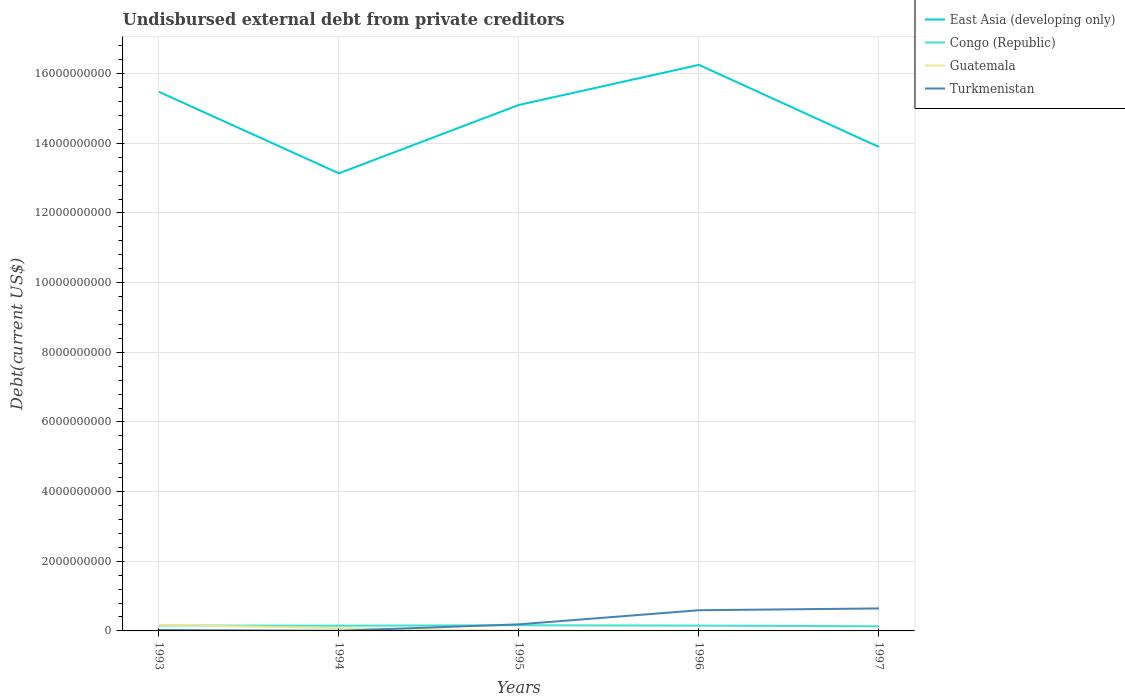Is the number of lines equal to the number of legend labels?
Provide a succinct answer. Yes. Across all years, what is the maximum total debt in East Asia (developing only)?
Keep it short and to the point. 1.31e+1. In which year was the total debt in Congo (Republic) maximum?
Provide a succinct answer. 1997. What is the total total debt in Guatemala in the graph?
Your answer should be compact. 4.01e+06. What is the difference between the highest and the second highest total debt in Turkmenistan?
Your answer should be very brief. 6.41e+08. How many years are there in the graph?
Provide a short and direct response. 5. What is the difference between two consecutive major ticks on the Y-axis?
Offer a very short reply. 2.00e+09. Does the graph contain grids?
Your answer should be very brief. Yes. Where does the legend appear in the graph?
Your answer should be compact. Top right. How are the legend labels stacked?
Your response must be concise. Vertical. What is the title of the graph?
Your answer should be very brief. Undisbursed external debt from private creditors. What is the label or title of the Y-axis?
Provide a short and direct response. Debt(current US$). What is the Debt(current US$) in East Asia (developing only) in 1993?
Offer a terse response. 1.55e+1. What is the Debt(current US$) in Congo (Republic) in 1993?
Give a very brief answer. 1.55e+08. What is the Debt(current US$) in Guatemala in 1993?
Your answer should be compact. 1.73e+08. What is the Debt(current US$) of Turkmenistan in 1993?
Ensure brevity in your answer.  2.70e+07. What is the Debt(current US$) in East Asia (developing only) in 1994?
Ensure brevity in your answer.  1.31e+1. What is the Debt(current US$) in Congo (Republic) in 1994?
Your response must be concise. 1.50e+08. What is the Debt(current US$) of Guatemala in 1994?
Provide a short and direct response. 7.89e+07. What is the Debt(current US$) of Turkmenistan in 1994?
Keep it short and to the point. 4.59e+06. What is the Debt(current US$) in East Asia (developing only) in 1995?
Your answer should be compact. 1.51e+1. What is the Debt(current US$) of Congo (Republic) in 1995?
Ensure brevity in your answer.  1.63e+08. What is the Debt(current US$) of Guatemala in 1995?
Provide a short and direct response. 7.03e+06. What is the Debt(current US$) in Turkmenistan in 1995?
Keep it short and to the point. 1.89e+08. What is the Debt(current US$) in East Asia (developing only) in 1996?
Your answer should be compact. 1.63e+1. What is the Debt(current US$) in Congo (Republic) in 1996?
Give a very brief answer. 1.53e+08. What is the Debt(current US$) in Guatemala in 1996?
Offer a very short reply. 5.85e+06. What is the Debt(current US$) of Turkmenistan in 1996?
Your answer should be very brief. 5.94e+08. What is the Debt(current US$) in East Asia (developing only) in 1997?
Provide a short and direct response. 1.39e+1. What is the Debt(current US$) in Congo (Republic) in 1997?
Offer a very short reply. 1.34e+08. What is the Debt(current US$) of Guatemala in 1997?
Offer a terse response. 1.84e+06. What is the Debt(current US$) of Turkmenistan in 1997?
Provide a short and direct response. 6.46e+08. Across all years, what is the maximum Debt(current US$) in East Asia (developing only)?
Your answer should be compact. 1.63e+1. Across all years, what is the maximum Debt(current US$) in Congo (Republic)?
Give a very brief answer. 1.63e+08. Across all years, what is the maximum Debt(current US$) of Guatemala?
Your response must be concise. 1.73e+08. Across all years, what is the maximum Debt(current US$) in Turkmenistan?
Your answer should be compact. 6.46e+08. Across all years, what is the minimum Debt(current US$) of East Asia (developing only)?
Your answer should be compact. 1.31e+1. Across all years, what is the minimum Debt(current US$) of Congo (Republic)?
Give a very brief answer. 1.34e+08. Across all years, what is the minimum Debt(current US$) of Guatemala?
Make the answer very short. 1.84e+06. Across all years, what is the minimum Debt(current US$) in Turkmenistan?
Provide a short and direct response. 4.59e+06. What is the total Debt(current US$) of East Asia (developing only) in the graph?
Offer a very short reply. 7.39e+1. What is the total Debt(current US$) of Congo (Republic) in the graph?
Your answer should be compact. 7.55e+08. What is the total Debt(current US$) in Guatemala in the graph?
Your answer should be very brief. 2.66e+08. What is the total Debt(current US$) in Turkmenistan in the graph?
Offer a very short reply. 1.46e+09. What is the difference between the Debt(current US$) of East Asia (developing only) in 1993 and that in 1994?
Your answer should be very brief. 2.34e+09. What is the difference between the Debt(current US$) of Congo (Republic) in 1993 and that in 1994?
Provide a succinct answer. 4.70e+06. What is the difference between the Debt(current US$) in Guatemala in 1993 and that in 1994?
Provide a short and direct response. 9.38e+07. What is the difference between the Debt(current US$) of Turkmenistan in 1993 and that in 1994?
Your answer should be very brief. 2.25e+07. What is the difference between the Debt(current US$) in East Asia (developing only) in 1993 and that in 1995?
Offer a terse response. 3.78e+08. What is the difference between the Debt(current US$) in Congo (Republic) in 1993 and that in 1995?
Make the answer very short. -8.08e+06. What is the difference between the Debt(current US$) of Guatemala in 1993 and that in 1995?
Offer a terse response. 1.66e+08. What is the difference between the Debt(current US$) of Turkmenistan in 1993 and that in 1995?
Make the answer very short. -1.62e+08. What is the difference between the Debt(current US$) in East Asia (developing only) in 1993 and that in 1996?
Keep it short and to the point. -7.72e+08. What is the difference between the Debt(current US$) of Congo (Republic) in 1993 and that in 1996?
Offer a very short reply. 2.43e+06. What is the difference between the Debt(current US$) in Guatemala in 1993 and that in 1996?
Your answer should be compact. 1.67e+08. What is the difference between the Debt(current US$) of Turkmenistan in 1993 and that in 1996?
Provide a succinct answer. -5.67e+08. What is the difference between the Debt(current US$) in East Asia (developing only) in 1993 and that in 1997?
Offer a very short reply. 1.58e+09. What is the difference between the Debt(current US$) in Congo (Republic) in 1993 and that in 1997?
Your answer should be very brief. 2.16e+07. What is the difference between the Debt(current US$) of Guatemala in 1993 and that in 1997?
Give a very brief answer. 1.71e+08. What is the difference between the Debt(current US$) of Turkmenistan in 1993 and that in 1997?
Provide a succinct answer. -6.19e+08. What is the difference between the Debt(current US$) of East Asia (developing only) in 1994 and that in 1995?
Offer a very short reply. -1.96e+09. What is the difference between the Debt(current US$) of Congo (Republic) in 1994 and that in 1995?
Make the answer very short. -1.28e+07. What is the difference between the Debt(current US$) of Guatemala in 1994 and that in 1995?
Give a very brief answer. 7.19e+07. What is the difference between the Debt(current US$) in Turkmenistan in 1994 and that in 1995?
Keep it short and to the point. -1.84e+08. What is the difference between the Debt(current US$) in East Asia (developing only) in 1994 and that in 1996?
Offer a very short reply. -3.11e+09. What is the difference between the Debt(current US$) of Congo (Republic) in 1994 and that in 1996?
Provide a succinct answer. -2.27e+06. What is the difference between the Debt(current US$) in Guatemala in 1994 and that in 1996?
Offer a terse response. 7.30e+07. What is the difference between the Debt(current US$) of Turkmenistan in 1994 and that in 1996?
Your response must be concise. -5.89e+08. What is the difference between the Debt(current US$) of East Asia (developing only) in 1994 and that in 1997?
Your response must be concise. -7.57e+08. What is the difference between the Debt(current US$) in Congo (Republic) in 1994 and that in 1997?
Keep it short and to the point. 1.69e+07. What is the difference between the Debt(current US$) of Guatemala in 1994 and that in 1997?
Your response must be concise. 7.70e+07. What is the difference between the Debt(current US$) in Turkmenistan in 1994 and that in 1997?
Your response must be concise. -6.41e+08. What is the difference between the Debt(current US$) of East Asia (developing only) in 1995 and that in 1996?
Keep it short and to the point. -1.15e+09. What is the difference between the Debt(current US$) of Congo (Republic) in 1995 and that in 1996?
Provide a short and direct response. 1.05e+07. What is the difference between the Debt(current US$) in Guatemala in 1995 and that in 1996?
Your answer should be very brief. 1.18e+06. What is the difference between the Debt(current US$) of Turkmenistan in 1995 and that in 1996?
Offer a very short reply. -4.05e+08. What is the difference between the Debt(current US$) in East Asia (developing only) in 1995 and that in 1997?
Give a very brief answer. 1.21e+09. What is the difference between the Debt(current US$) of Congo (Republic) in 1995 and that in 1997?
Your answer should be compact. 2.97e+07. What is the difference between the Debt(current US$) in Guatemala in 1995 and that in 1997?
Give a very brief answer. 5.19e+06. What is the difference between the Debt(current US$) of Turkmenistan in 1995 and that in 1997?
Offer a very short reply. -4.57e+08. What is the difference between the Debt(current US$) of East Asia (developing only) in 1996 and that in 1997?
Offer a very short reply. 2.36e+09. What is the difference between the Debt(current US$) of Congo (Republic) in 1996 and that in 1997?
Provide a succinct answer. 1.92e+07. What is the difference between the Debt(current US$) in Guatemala in 1996 and that in 1997?
Offer a very short reply. 4.01e+06. What is the difference between the Debt(current US$) of Turkmenistan in 1996 and that in 1997?
Ensure brevity in your answer.  -5.17e+07. What is the difference between the Debt(current US$) in East Asia (developing only) in 1993 and the Debt(current US$) in Congo (Republic) in 1994?
Provide a short and direct response. 1.53e+1. What is the difference between the Debt(current US$) of East Asia (developing only) in 1993 and the Debt(current US$) of Guatemala in 1994?
Make the answer very short. 1.54e+1. What is the difference between the Debt(current US$) in East Asia (developing only) in 1993 and the Debt(current US$) in Turkmenistan in 1994?
Offer a very short reply. 1.55e+1. What is the difference between the Debt(current US$) in Congo (Republic) in 1993 and the Debt(current US$) in Guatemala in 1994?
Your answer should be very brief. 7.63e+07. What is the difference between the Debt(current US$) in Congo (Republic) in 1993 and the Debt(current US$) in Turkmenistan in 1994?
Your response must be concise. 1.51e+08. What is the difference between the Debt(current US$) of Guatemala in 1993 and the Debt(current US$) of Turkmenistan in 1994?
Keep it short and to the point. 1.68e+08. What is the difference between the Debt(current US$) of East Asia (developing only) in 1993 and the Debt(current US$) of Congo (Republic) in 1995?
Your answer should be very brief. 1.53e+1. What is the difference between the Debt(current US$) of East Asia (developing only) in 1993 and the Debt(current US$) of Guatemala in 1995?
Your answer should be compact. 1.55e+1. What is the difference between the Debt(current US$) of East Asia (developing only) in 1993 and the Debt(current US$) of Turkmenistan in 1995?
Offer a terse response. 1.53e+1. What is the difference between the Debt(current US$) in Congo (Republic) in 1993 and the Debt(current US$) in Guatemala in 1995?
Provide a short and direct response. 1.48e+08. What is the difference between the Debt(current US$) of Congo (Republic) in 1993 and the Debt(current US$) of Turkmenistan in 1995?
Provide a succinct answer. -3.35e+07. What is the difference between the Debt(current US$) of Guatemala in 1993 and the Debt(current US$) of Turkmenistan in 1995?
Give a very brief answer. -1.60e+07. What is the difference between the Debt(current US$) in East Asia (developing only) in 1993 and the Debt(current US$) in Congo (Republic) in 1996?
Provide a short and direct response. 1.53e+1. What is the difference between the Debt(current US$) in East Asia (developing only) in 1993 and the Debt(current US$) in Guatemala in 1996?
Offer a terse response. 1.55e+1. What is the difference between the Debt(current US$) of East Asia (developing only) in 1993 and the Debt(current US$) of Turkmenistan in 1996?
Give a very brief answer. 1.49e+1. What is the difference between the Debt(current US$) of Congo (Republic) in 1993 and the Debt(current US$) of Guatemala in 1996?
Give a very brief answer. 1.49e+08. What is the difference between the Debt(current US$) of Congo (Republic) in 1993 and the Debt(current US$) of Turkmenistan in 1996?
Your answer should be compact. -4.39e+08. What is the difference between the Debt(current US$) in Guatemala in 1993 and the Debt(current US$) in Turkmenistan in 1996?
Provide a succinct answer. -4.21e+08. What is the difference between the Debt(current US$) of East Asia (developing only) in 1993 and the Debt(current US$) of Congo (Republic) in 1997?
Your response must be concise. 1.53e+1. What is the difference between the Debt(current US$) in East Asia (developing only) in 1993 and the Debt(current US$) in Guatemala in 1997?
Provide a short and direct response. 1.55e+1. What is the difference between the Debt(current US$) in East Asia (developing only) in 1993 and the Debt(current US$) in Turkmenistan in 1997?
Your answer should be compact. 1.48e+1. What is the difference between the Debt(current US$) in Congo (Republic) in 1993 and the Debt(current US$) in Guatemala in 1997?
Make the answer very short. 1.53e+08. What is the difference between the Debt(current US$) in Congo (Republic) in 1993 and the Debt(current US$) in Turkmenistan in 1997?
Offer a terse response. -4.90e+08. What is the difference between the Debt(current US$) in Guatemala in 1993 and the Debt(current US$) in Turkmenistan in 1997?
Offer a terse response. -4.73e+08. What is the difference between the Debt(current US$) of East Asia (developing only) in 1994 and the Debt(current US$) of Congo (Republic) in 1995?
Keep it short and to the point. 1.30e+1. What is the difference between the Debt(current US$) of East Asia (developing only) in 1994 and the Debt(current US$) of Guatemala in 1995?
Give a very brief answer. 1.31e+1. What is the difference between the Debt(current US$) of East Asia (developing only) in 1994 and the Debt(current US$) of Turkmenistan in 1995?
Offer a terse response. 1.29e+1. What is the difference between the Debt(current US$) in Congo (Republic) in 1994 and the Debt(current US$) in Guatemala in 1995?
Your answer should be very brief. 1.43e+08. What is the difference between the Debt(current US$) of Congo (Republic) in 1994 and the Debt(current US$) of Turkmenistan in 1995?
Your answer should be compact. -3.82e+07. What is the difference between the Debt(current US$) of Guatemala in 1994 and the Debt(current US$) of Turkmenistan in 1995?
Keep it short and to the point. -1.10e+08. What is the difference between the Debt(current US$) of East Asia (developing only) in 1994 and the Debt(current US$) of Congo (Republic) in 1996?
Ensure brevity in your answer.  1.30e+1. What is the difference between the Debt(current US$) in East Asia (developing only) in 1994 and the Debt(current US$) in Guatemala in 1996?
Give a very brief answer. 1.31e+1. What is the difference between the Debt(current US$) in East Asia (developing only) in 1994 and the Debt(current US$) in Turkmenistan in 1996?
Ensure brevity in your answer.  1.25e+1. What is the difference between the Debt(current US$) in Congo (Republic) in 1994 and the Debt(current US$) in Guatemala in 1996?
Provide a short and direct response. 1.45e+08. What is the difference between the Debt(current US$) of Congo (Republic) in 1994 and the Debt(current US$) of Turkmenistan in 1996?
Offer a very short reply. -4.43e+08. What is the difference between the Debt(current US$) in Guatemala in 1994 and the Debt(current US$) in Turkmenistan in 1996?
Offer a terse response. -5.15e+08. What is the difference between the Debt(current US$) of East Asia (developing only) in 1994 and the Debt(current US$) of Congo (Republic) in 1997?
Offer a terse response. 1.30e+1. What is the difference between the Debt(current US$) of East Asia (developing only) in 1994 and the Debt(current US$) of Guatemala in 1997?
Your answer should be compact. 1.31e+1. What is the difference between the Debt(current US$) of East Asia (developing only) in 1994 and the Debt(current US$) of Turkmenistan in 1997?
Your answer should be very brief. 1.25e+1. What is the difference between the Debt(current US$) of Congo (Republic) in 1994 and the Debt(current US$) of Guatemala in 1997?
Provide a succinct answer. 1.49e+08. What is the difference between the Debt(current US$) in Congo (Republic) in 1994 and the Debt(current US$) in Turkmenistan in 1997?
Ensure brevity in your answer.  -4.95e+08. What is the difference between the Debt(current US$) in Guatemala in 1994 and the Debt(current US$) in Turkmenistan in 1997?
Ensure brevity in your answer.  -5.67e+08. What is the difference between the Debt(current US$) in East Asia (developing only) in 1995 and the Debt(current US$) in Congo (Republic) in 1996?
Give a very brief answer. 1.49e+1. What is the difference between the Debt(current US$) in East Asia (developing only) in 1995 and the Debt(current US$) in Guatemala in 1996?
Your answer should be compact. 1.51e+1. What is the difference between the Debt(current US$) of East Asia (developing only) in 1995 and the Debt(current US$) of Turkmenistan in 1996?
Keep it short and to the point. 1.45e+1. What is the difference between the Debt(current US$) in Congo (Republic) in 1995 and the Debt(current US$) in Guatemala in 1996?
Keep it short and to the point. 1.57e+08. What is the difference between the Debt(current US$) in Congo (Republic) in 1995 and the Debt(current US$) in Turkmenistan in 1996?
Offer a very short reply. -4.31e+08. What is the difference between the Debt(current US$) in Guatemala in 1995 and the Debt(current US$) in Turkmenistan in 1996?
Provide a succinct answer. -5.87e+08. What is the difference between the Debt(current US$) in East Asia (developing only) in 1995 and the Debt(current US$) in Congo (Republic) in 1997?
Ensure brevity in your answer.  1.50e+1. What is the difference between the Debt(current US$) in East Asia (developing only) in 1995 and the Debt(current US$) in Guatemala in 1997?
Your answer should be compact. 1.51e+1. What is the difference between the Debt(current US$) in East Asia (developing only) in 1995 and the Debt(current US$) in Turkmenistan in 1997?
Your response must be concise. 1.45e+1. What is the difference between the Debt(current US$) of Congo (Republic) in 1995 and the Debt(current US$) of Guatemala in 1997?
Your answer should be very brief. 1.61e+08. What is the difference between the Debt(current US$) in Congo (Republic) in 1995 and the Debt(current US$) in Turkmenistan in 1997?
Make the answer very short. -4.82e+08. What is the difference between the Debt(current US$) in Guatemala in 1995 and the Debt(current US$) in Turkmenistan in 1997?
Ensure brevity in your answer.  -6.39e+08. What is the difference between the Debt(current US$) in East Asia (developing only) in 1996 and the Debt(current US$) in Congo (Republic) in 1997?
Give a very brief answer. 1.61e+1. What is the difference between the Debt(current US$) of East Asia (developing only) in 1996 and the Debt(current US$) of Guatemala in 1997?
Your answer should be very brief. 1.63e+1. What is the difference between the Debt(current US$) in East Asia (developing only) in 1996 and the Debt(current US$) in Turkmenistan in 1997?
Your response must be concise. 1.56e+1. What is the difference between the Debt(current US$) of Congo (Republic) in 1996 and the Debt(current US$) of Guatemala in 1997?
Provide a succinct answer. 1.51e+08. What is the difference between the Debt(current US$) of Congo (Republic) in 1996 and the Debt(current US$) of Turkmenistan in 1997?
Provide a short and direct response. -4.93e+08. What is the difference between the Debt(current US$) of Guatemala in 1996 and the Debt(current US$) of Turkmenistan in 1997?
Your response must be concise. -6.40e+08. What is the average Debt(current US$) in East Asia (developing only) per year?
Offer a very short reply. 1.48e+1. What is the average Debt(current US$) in Congo (Republic) per year?
Offer a very short reply. 1.51e+08. What is the average Debt(current US$) of Guatemala per year?
Ensure brevity in your answer.  5.33e+07. What is the average Debt(current US$) of Turkmenistan per year?
Provide a short and direct response. 2.92e+08. In the year 1993, what is the difference between the Debt(current US$) in East Asia (developing only) and Debt(current US$) in Congo (Republic)?
Your answer should be compact. 1.53e+1. In the year 1993, what is the difference between the Debt(current US$) in East Asia (developing only) and Debt(current US$) in Guatemala?
Provide a short and direct response. 1.53e+1. In the year 1993, what is the difference between the Debt(current US$) of East Asia (developing only) and Debt(current US$) of Turkmenistan?
Make the answer very short. 1.55e+1. In the year 1993, what is the difference between the Debt(current US$) of Congo (Republic) and Debt(current US$) of Guatemala?
Ensure brevity in your answer.  -1.75e+07. In the year 1993, what is the difference between the Debt(current US$) of Congo (Republic) and Debt(current US$) of Turkmenistan?
Your answer should be very brief. 1.28e+08. In the year 1993, what is the difference between the Debt(current US$) of Guatemala and Debt(current US$) of Turkmenistan?
Make the answer very short. 1.46e+08. In the year 1994, what is the difference between the Debt(current US$) of East Asia (developing only) and Debt(current US$) of Congo (Republic)?
Offer a terse response. 1.30e+1. In the year 1994, what is the difference between the Debt(current US$) of East Asia (developing only) and Debt(current US$) of Guatemala?
Provide a succinct answer. 1.31e+1. In the year 1994, what is the difference between the Debt(current US$) in East Asia (developing only) and Debt(current US$) in Turkmenistan?
Offer a very short reply. 1.31e+1. In the year 1994, what is the difference between the Debt(current US$) of Congo (Republic) and Debt(current US$) of Guatemala?
Provide a succinct answer. 7.16e+07. In the year 1994, what is the difference between the Debt(current US$) in Congo (Republic) and Debt(current US$) in Turkmenistan?
Offer a terse response. 1.46e+08. In the year 1994, what is the difference between the Debt(current US$) of Guatemala and Debt(current US$) of Turkmenistan?
Ensure brevity in your answer.  7.43e+07. In the year 1995, what is the difference between the Debt(current US$) in East Asia (developing only) and Debt(current US$) in Congo (Republic)?
Ensure brevity in your answer.  1.49e+1. In the year 1995, what is the difference between the Debt(current US$) in East Asia (developing only) and Debt(current US$) in Guatemala?
Ensure brevity in your answer.  1.51e+1. In the year 1995, what is the difference between the Debt(current US$) of East Asia (developing only) and Debt(current US$) of Turkmenistan?
Offer a terse response. 1.49e+1. In the year 1995, what is the difference between the Debt(current US$) of Congo (Republic) and Debt(current US$) of Guatemala?
Your answer should be compact. 1.56e+08. In the year 1995, what is the difference between the Debt(current US$) of Congo (Republic) and Debt(current US$) of Turkmenistan?
Your answer should be compact. -2.54e+07. In the year 1995, what is the difference between the Debt(current US$) in Guatemala and Debt(current US$) in Turkmenistan?
Offer a terse response. -1.82e+08. In the year 1996, what is the difference between the Debt(current US$) of East Asia (developing only) and Debt(current US$) of Congo (Republic)?
Your answer should be very brief. 1.61e+1. In the year 1996, what is the difference between the Debt(current US$) in East Asia (developing only) and Debt(current US$) in Guatemala?
Offer a terse response. 1.62e+1. In the year 1996, what is the difference between the Debt(current US$) of East Asia (developing only) and Debt(current US$) of Turkmenistan?
Provide a succinct answer. 1.57e+1. In the year 1996, what is the difference between the Debt(current US$) in Congo (Republic) and Debt(current US$) in Guatemala?
Offer a very short reply. 1.47e+08. In the year 1996, what is the difference between the Debt(current US$) in Congo (Republic) and Debt(current US$) in Turkmenistan?
Keep it short and to the point. -4.41e+08. In the year 1996, what is the difference between the Debt(current US$) in Guatemala and Debt(current US$) in Turkmenistan?
Make the answer very short. -5.88e+08. In the year 1997, what is the difference between the Debt(current US$) in East Asia (developing only) and Debt(current US$) in Congo (Republic)?
Your answer should be very brief. 1.38e+1. In the year 1997, what is the difference between the Debt(current US$) in East Asia (developing only) and Debt(current US$) in Guatemala?
Give a very brief answer. 1.39e+1. In the year 1997, what is the difference between the Debt(current US$) of East Asia (developing only) and Debt(current US$) of Turkmenistan?
Your answer should be very brief. 1.32e+1. In the year 1997, what is the difference between the Debt(current US$) of Congo (Republic) and Debt(current US$) of Guatemala?
Your answer should be very brief. 1.32e+08. In the year 1997, what is the difference between the Debt(current US$) of Congo (Republic) and Debt(current US$) of Turkmenistan?
Offer a very short reply. -5.12e+08. In the year 1997, what is the difference between the Debt(current US$) in Guatemala and Debt(current US$) in Turkmenistan?
Offer a very short reply. -6.44e+08. What is the ratio of the Debt(current US$) of East Asia (developing only) in 1993 to that in 1994?
Offer a terse response. 1.18. What is the ratio of the Debt(current US$) in Congo (Republic) in 1993 to that in 1994?
Your answer should be compact. 1.03. What is the ratio of the Debt(current US$) in Guatemala in 1993 to that in 1994?
Keep it short and to the point. 2.19. What is the ratio of the Debt(current US$) of Turkmenistan in 1993 to that in 1994?
Keep it short and to the point. 5.9. What is the ratio of the Debt(current US$) of East Asia (developing only) in 1993 to that in 1995?
Provide a succinct answer. 1.02. What is the ratio of the Debt(current US$) in Congo (Republic) in 1993 to that in 1995?
Offer a terse response. 0.95. What is the ratio of the Debt(current US$) of Guatemala in 1993 to that in 1995?
Provide a succinct answer. 24.56. What is the ratio of the Debt(current US$) in Turkmenistan in 1993 to that in 1995?
Keep it short and to the point. 0.14. What is the ratio of the Debt(current US$) of East Asia (developing only) in 1993 to that in 1996?
Make the answer very short. 0.95. What is the ratio of the Debt(current US$) of Congo (Republic) in 1993 to that in 1996?
Provide a succinct answer. 1.02. What is the ratio of the Debt(current US$) in Guatemala in 1993 to that in 1996?
Offer a terse response. 29.51. What is the ratio of the Debt(current US$) in Turkmenistan in 1993 to that in 1996?
Provide a short and direct response. 0.05. What is the ratio of the Debt(current US$) in East Asia (developing only) in 1993 to that in 1997?
Provide a short and direct response. 1.11. What is the ratio of the Debt(current US$) in Congo (Republic) in 1993 to that in 1997?
Make the answer very short. 1.16. What is the ratio of the Debt(current US$) of Guatemala in 1993 to that in 1997?
Your answer should be very brief. 93.64. What is the ratio of the Debt(current US$) of Turkmenistan in 1993 to that in 1997?
Your response must be concise. 0.04. What is the ratio of the Debt(current US$) in East Asia (developing only) in 1994 to that in 1995?
Offer a terse response. 0.87. What is the ratio of the Debt(current US$) in Congo (Republic) in 1994 to that in 1995?
Make the answer very short. 0.92. What is the ratio of the Debt(current US$) of Guatemala in 1994 to that in 1995?
Provide a succinct answer. 11.22. What is the ratio of the Debt(current US$) of Turkmenistan in 1994 to that in 1995?
Offer a terse response. 0.02. What is the ratio of the Debt(current US$) in East Asia (developing only) in 1994 to that in 1996?
Give a very brief answer. 0.81. What is the ratio of the Debt(current US$) in Congo (Republic) in 1994 to that in 1996?
Your response must be concise. 0.99. What is the ratio of the Debt(current US$) in Guatemala in 1994 to that in 1996?
Give a very brief answer. 13.48. What is the ratio of the Debt(current US$) in Turkmenistan in 1994 to that in 1996?
Make the answer very short. 0.01. What is the ratio of the Debt(current US$) in East Asia (developing only) in 1994 to that in 1997?
Provide a short and direct response. 0.95. What is the ratio of the Debt(current US$) in Congo (Republic) in 1994 to that in 1997?
Provide a succinct answer. 1.13. What is the ratio of the Debt(current US$) in Guatemala in 1994 to that in 1997?
Ensure brevity in your answer.  42.78. What is the ratio of the Debt(current US$) in Turkmenistan in 1994 to that in 1997?
Keep it short and to the point. 0.01. What is the ratio of the Debt(current US$) in East Asia (developing only) in 1995 to that in 1996?
Keep it short and to the point. 0.93. What is the ratio of the Debt(current US$) in Congo (Republic) in 1995 to that in 1996?
Provide a succinct answer. 1.07. What is the ratio of the Debt(current US$) in Guatemala in 1995 to that in 1996?
Provide a short and direct response. 1.2. What is the ratio of the Debt(current US$) of Turkmenistan in 1995 to that in 1996?
Your response must be concise. 0.32. What is the ratio of the Debt(current US$) in East Asia (developing only) in 1995 to that in 1997?
Provide a succinct answer. 1.09. What is the ratio of the Debt(current US$) of Congo (Republic) in 1995 to that in 1997?
Offer a very short reply. 1.22. What is the ratio of the Debt(current US$) in Guatemala in 1995 to that in 1997?
Keep it short and to the point. 3.81. What is the ratio of the Debt(current US$) of Turkmenistan in 1995 to that in 1997?
Provide a succinct answer. 0.29. What is the ratio of the Debt(current US$) in East Asia (developing only) in 1996 to that in 1997?
Keep it short and to the point. 1.17. What is the ratio of the Debt(current US$) of Congo (Republic) in 1996 to that in 1997?
Make the answer very short. 1.14. What is the ratio of the Debt(current US$) in Guatemala in 1996 to that in 1997?
Your response must be concise. 3.17. What is the difference between the highest and the second highest Debt(current US$) in East Asia (developing only)?
Give a very brief answer. 7.72e+08. What is the difference between the highest and the second highest Debt(current US$) in Congo (Republic)?
Keep it short and to the point. 8.08e+06. What is the difference between the highest and the second highest Debt(current US$) in Guatemala?
Ensure brevity in your answer.  9.38e+07. What is the difference between the highest and the second highest Debt(current US$) in Turkmenistan?
Provide a succinct answer. 5.17e+07. What is the difference between the highest and the lowest Debt(current US$) of East Asia (developing only)?
Offer a terse response. 3.11e+09. What is the difference between the highest and the lowest Debt(current US$) of Congo (Republic)?
Your response must be concise. 2.97e+07. What is the difference between the highest and the lowest Debt(current US$) in Guatemala?
Offer a very short reply. 1.71e+08. What is the difference between the highest and the lowest Debt(current US$) in Turkmenistan?
Your answer should be very brief. 6.41e+08. 